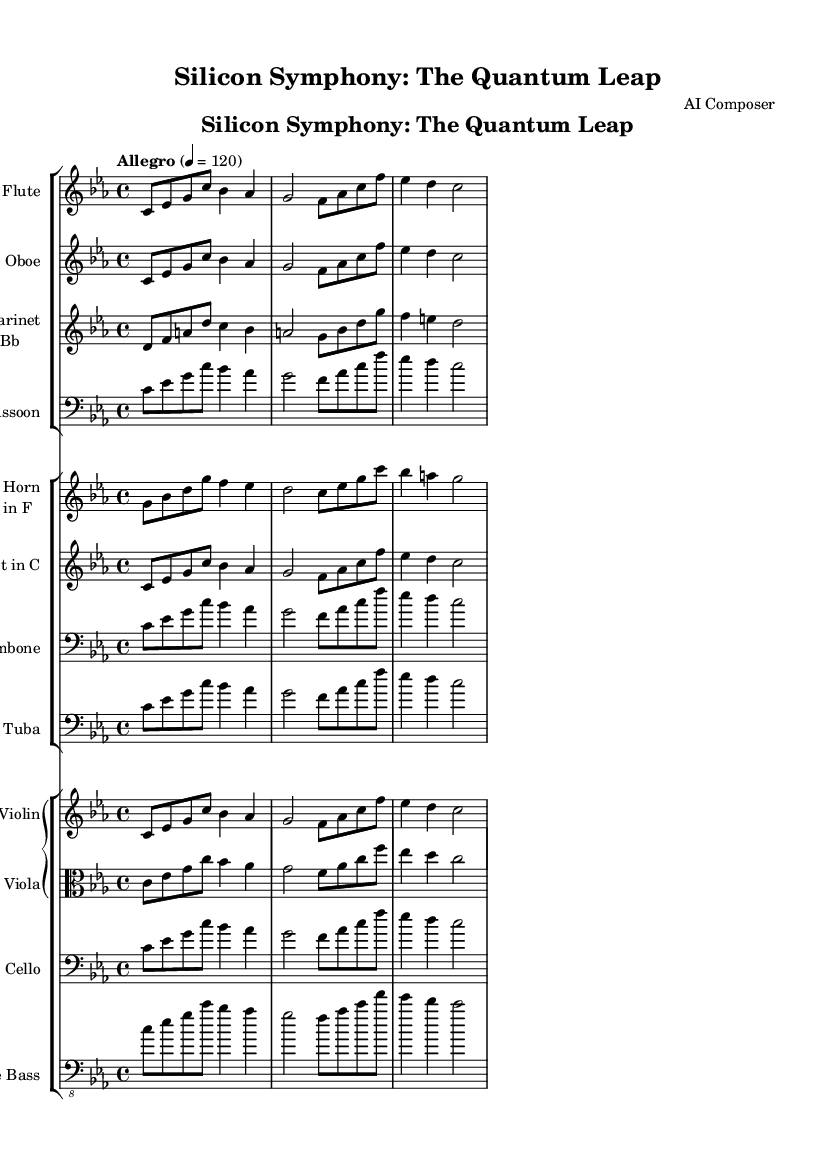What is the key signature of this music? The key signature of the piece is C minor, which has three flats (B flat, E flat, and A flat). This is indicated by the placement of the flat symbols in the staff at the beginning of the score.
Answer: C minor What is the time signature of this music? The time signature is 4/4, which is shown at the beginning of the score. This indicates that there are four beats per measure and the quarter note gets one beat.
Answer: 4/4 What is the tempo marking for this piece? The tempo marking is "Allegro," which indicates a fast and lively tempo. The exact metronome marking is 120 beats per minute, as shown in the score.
Answer: Allegro (120) Which instrument plays the main theme first? The main theme is first introduced by the flute, as shown in the score where the flute staff is listed first in the ensemble arrangement.
Answer: Flute How many different instrument sections are present in this symphony? There are three distinct sections: woodwinds, brass, and strings. Each section is indicated by separate staff groups in the score, making it clear how many sections are present.
Answer: Three What is the role of the double bass in this piece? The double bass, being the lowest string instrument, typically plays a supportive role by reinforcing the harmonic foundation and rhythm. Its music is written an octave higher than it sounds, which can be inferred from its placement in the staff and clef choice.
Answer: Harmonic foundation What is the significance of the title "Silicon Symphony: The Quantum Leap"? The title suggests a theme of evolution in technology, relating to concepts of advanced computing and processing power. "Quantum Leap" implies a significant advancement, which aligns with the futuristic context of the piece and its inspiration from semiconductor technology.
Answer: Evolution of technology 